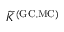Convert formula to latex. <formula><loc_0><loc_0><loc_500><loc_500>\widetilde { K } ^ { ( G C , M C ) }</formula> 